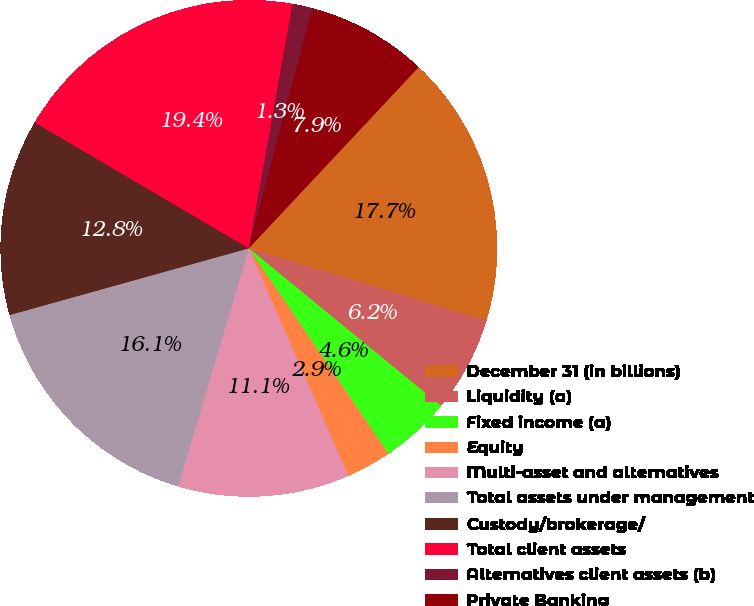Convert chart to OTSL. <chart><loc_0><loc_0><loc_500><loc_500><pie_chart><fcel>December 31 (in billions)<fcel>Liquidity (a)<fcel>Fixed income (a)<fcel>Equity<fcel>Multi-asset and alternatives<fcel>Total assets under management<fcel>Custody/brokerage/<fcel>Total client assets<fcel>Alternatives client assets (b)<fcel>Private Banking<nl><fcel>17.72%<fcel>6.22%<fcel>4.58%<fcel>2.94%<fcel>11.15%<fcel>16.08%<fcel>12.79%<fcel>19.36%<fcel>1.3%<fcel>7.87%<nl></chart> 